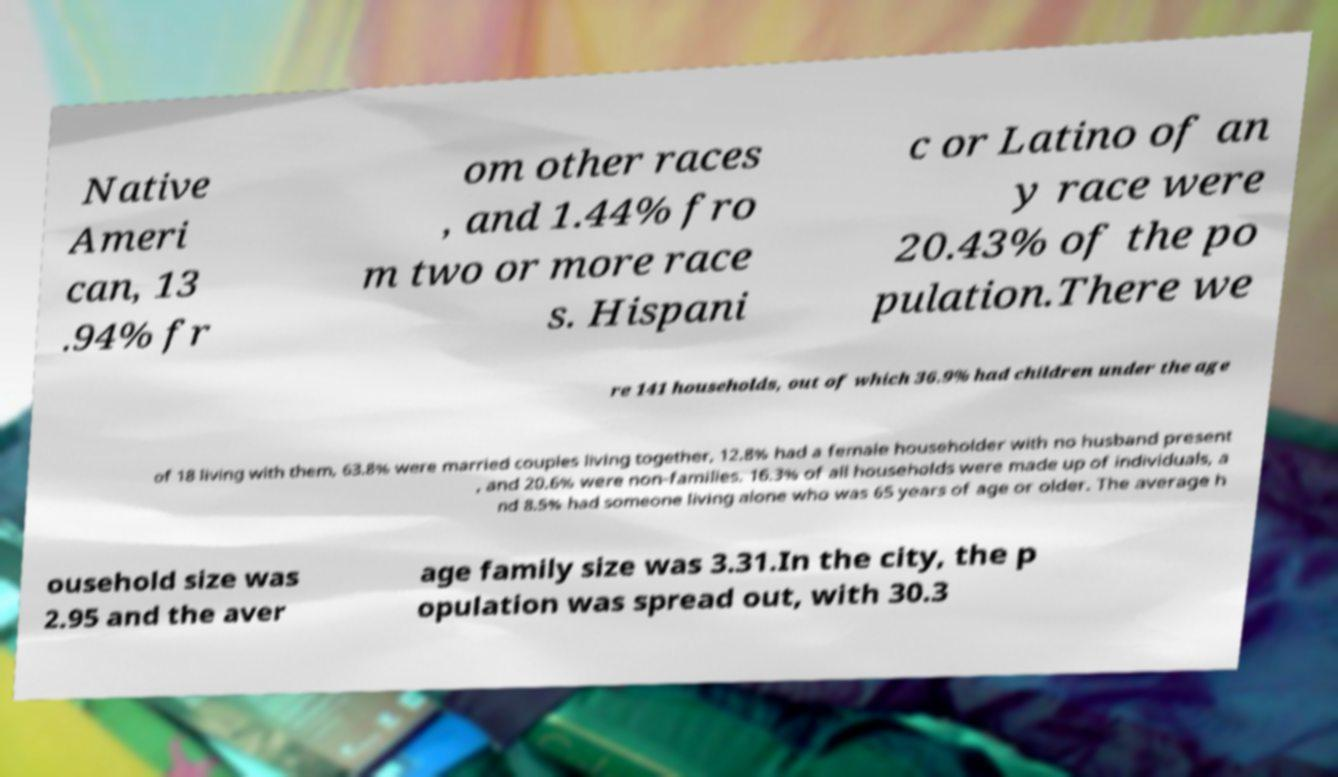Could you assist in decoding the text presented in this image and type it out clearly? Native Ameri can, 13 .94% fr om other races , and 1.44% fro m two or more race s. Hispani c or Latino of an y race were 20.43% of the po pulation.There we re 141 households, out of which 36.9% had children under the age of 18 living with them, 63.8% were married couples living together, 12.8% had a female householder with no husband present , and 20.6% were non-families. 16.3% of all households were made up of individuals, a nd 8.5% had someone living alone who was 65 years of age or older. The average h ousehold size was 2.95 and the aver age family size was 3.31.In the city, the p opulation was spread out, with 30.3 